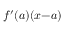Convert formula to latex. <formula><loc_0><loc_0><loc_500><loc_500>f ^ { \prime } ( a ) ( x { - } a )</formula> 